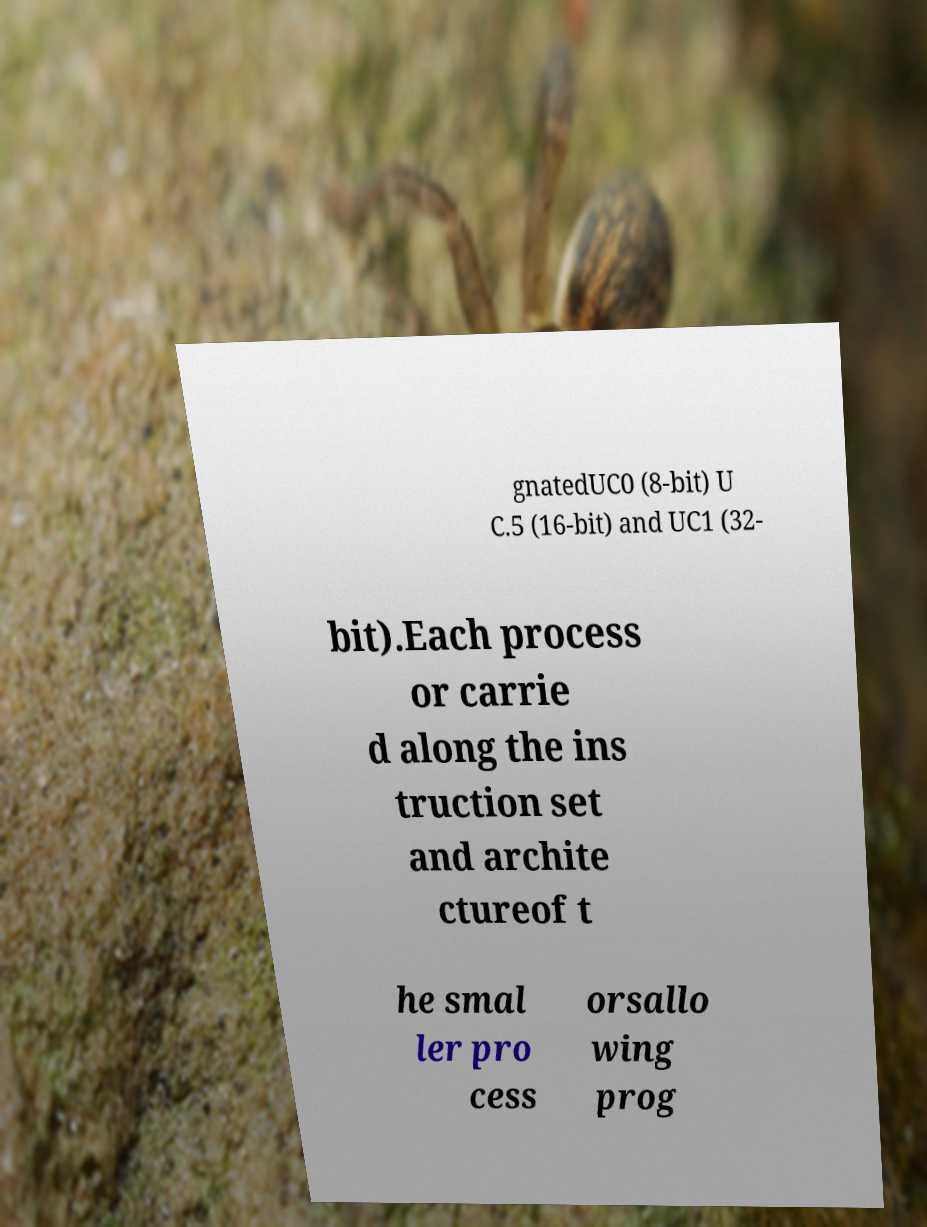I need the written content from this picture converted into text. Can you do that? gnatedUC0 (8-bit) U C.5 (16-bit) and UC1 (32- bit).Each process or carrie d along the ins truction set and archite ctureof t he smal ler pro cess orsallo wing prog 